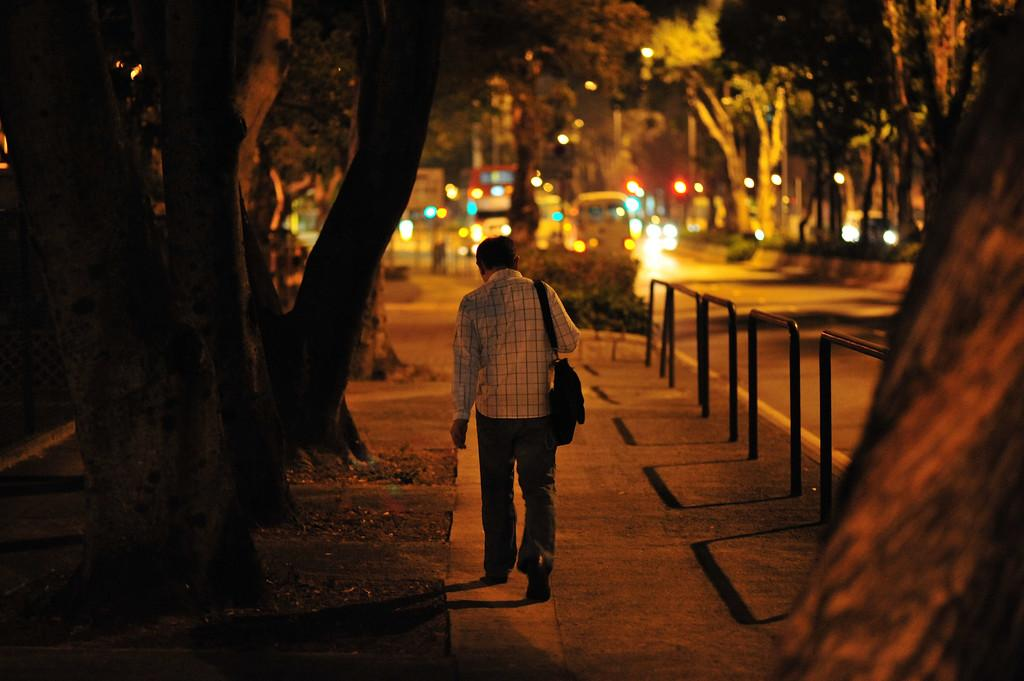Who is present in the image? There is a man in the image. What is the man doing in the image? The man is walking on a path. What can be seen on the right side of the man? There are iron rods on the right side of the man. What is visible in front of the man? There are vehicles on the road in front of the man. What type of natural elements can be seen in the image? There are trees visible in the image. What type of harmony can be heard in the image? There is no audible harmony present in the image, as it is a still photograph. 